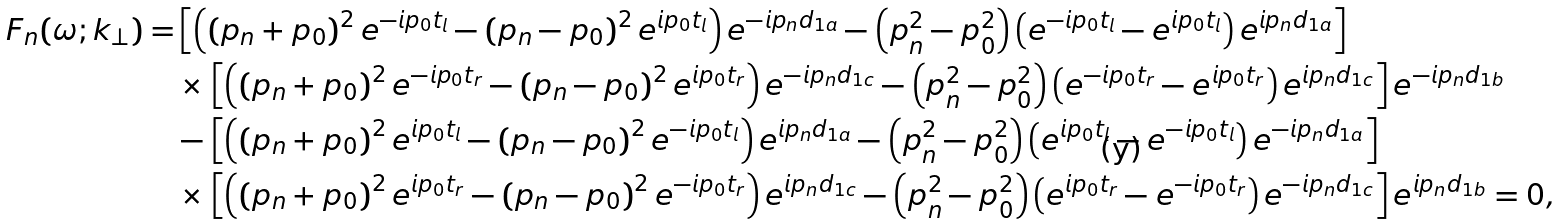<formula> <loc_0><loc_0><loc_500><loc_500>F _ { n } ( \omega ; k _ { \perp } ) = & \left [ \left ( \left ( p _ { n } + p _ { 0 } \right ) ^ { 2 } e ^ { - i p _ { 0 } t _ { l } } - \left ( p _ { n } - p _ { 0 } \right ) ^ { 2 } e ^ { i p _ { 0 } t _ { l } } \right ) e ^ { - i p _ { n } d _ { 1 a } } - \left ( p _ { n } ^ { 2 } - p _ { 0 } ^ { 2 } \right ) \left ( e ^ { - i p _ { 0 } t _ { l } } - e ^ { i p _ { 0 } t _ { l } } \right ) e ^ { i p _ { n } d _ { 1 a } } \right ] \\ & \times \left [ \left ( \left ( p _ { n } + p _ { 0 } \right ) ^ { 2 } e ^ { - i p _ { 0 } t _ { r } } - \left ( p _ { n } - p _ { 0 } \right ) ^ { 2 } e ^ { i p _ { 0 } t _ { r } } \right ) e ^ { - i p _ { n } d _ { 1 c } } - \left ( p _ { n } ^ { 2 } - p _ { 0 } ^ { 2 } \right ) \left ( e ^ { - i p _ { 0 } t _ { r } } - e ^ { i p _ { 0 } t _ { r } } \right ) e ^ { i p _ { n } d _ { 1 c } } \right ] e ^ { - i p _ { n } d _ { 1 b } } \\ & - \left [ \left ( \left ( p _ { n } + p _ { 0 } \right ) ^ { 2 } e ^ { i p _ { 0 } t _ { l } } - \left ( p _ { n } - p _ { 0 } \right ) ^ { 2 } e ^ { - i p _ { 0 } t _ { l } } \right ) e ^ { i p _ { n } d _ { 1 a } } - \left ( p _ { n } ^ { 2 } - p _ { 0 } ^ { 2 } \right ) \left ( e ^ { i p _ { 0 } t _ { l } } - e ^ { - i p _ { 0 } t _ { l } } \right ) e ^ { - i p _ { n } d _ { 1 a } } \right ] \\ & \times \left [ \left ( \left ( p _ { n } + p _ { 0 } \right ) ^ { 2 } e ^ { i p _ { 0 } t _ { r } } - \left ( p _ { n } - p _ { 0 } \right ) ^ { 2 } e ^ { - i p _ { 0 } t _ { r } } \right ) e ^ { i p _ { n } d _ { 1 c } } - \left ( p _ { n } ^ { 2 } - p _ { 0 } ^ { 2 } \right ) \left ( e ^ { i p _ { 0 } t _ { r } } - e ^ { - i p _ { 0 } t _ { r } } \right ) e ^ { - i p _ { n } d _ { 1 c } } \right ] e ^ { i p _ { n } d _ { 1 b } } = 0 ,</formula> 